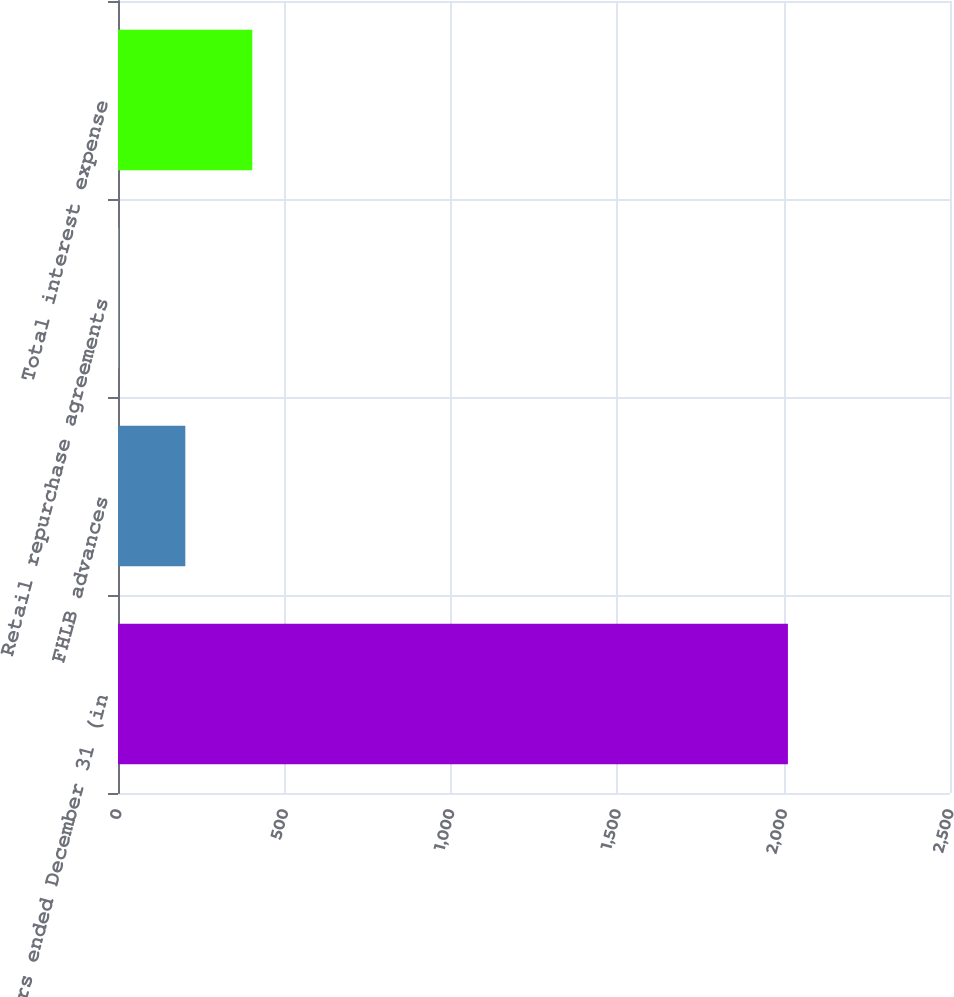Convert chart. <chart><loc_0><loc_0><loc_500><loc_500><bar_chart><fcel>Years ended December 31 (in<fcel>FHLB advances<fcel>Retail repurchase agreements<fcel>Total interest expense<nl><fcel>2013<fcel>202.29<fcel>1.1<fcel>403.48<nl></chart> 